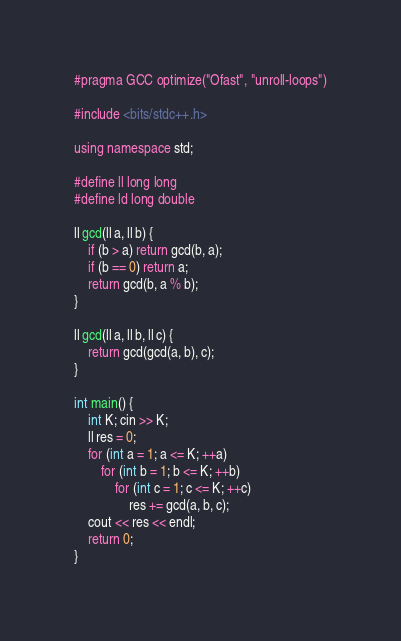<code> <loc_0><loc_0><loc_500><loc_500><_C++_>#pragma GCC optimize("Ofast", "unroll-loops")

#include <bits/stdc++.h>

using namespace std;

#define ll long long
#define ld long double

ll gcd(ll a, ll b) {
	if (b > a) return gcd(b, a);
	if (b == 0) return a;
	return gcd(b, a % b);
}

ll gcd(ll a, ll b, ll c) {
	return gcd(gcd(a, b), c);
}

int main() {
	int K; cin >> K;
	ll res = 0;
	for (int a = 1; a <= K; ++a)
		for (int b = 1; b <= K; ++b)
			for (int c = 1; c <= K; ++c)
				res += gcd(a, b, c);
	cout << res << endl;
	return 0;
}</code> 